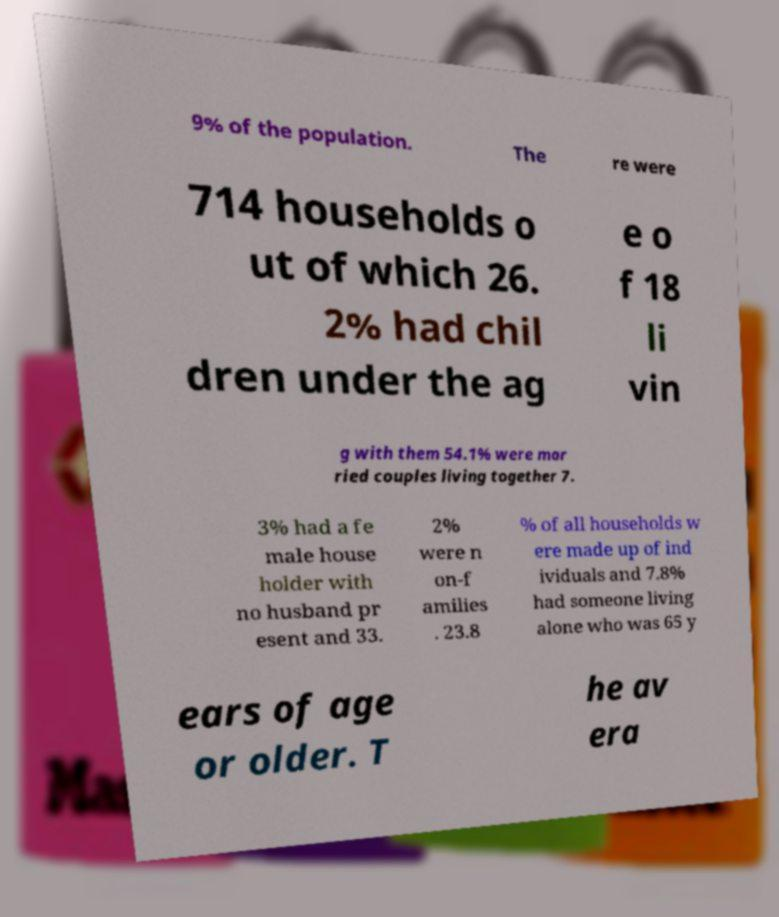Could you assist in decoding the text presented in this image and type it out clearly? 9% of the population. The re were 714 households o ut of which 26. 2% had chil dren under the ag e o f 18 li vin g with them 54.1% were mar ried couples living together 7. 3% had a fe male house holder with no husband pr esent and 33. 2% were n on-f amilies . 23.8 % of all households w ere made up of ind ividuals and 7.8% had someone living alone who was 65 y ears of age or older. T he av era 